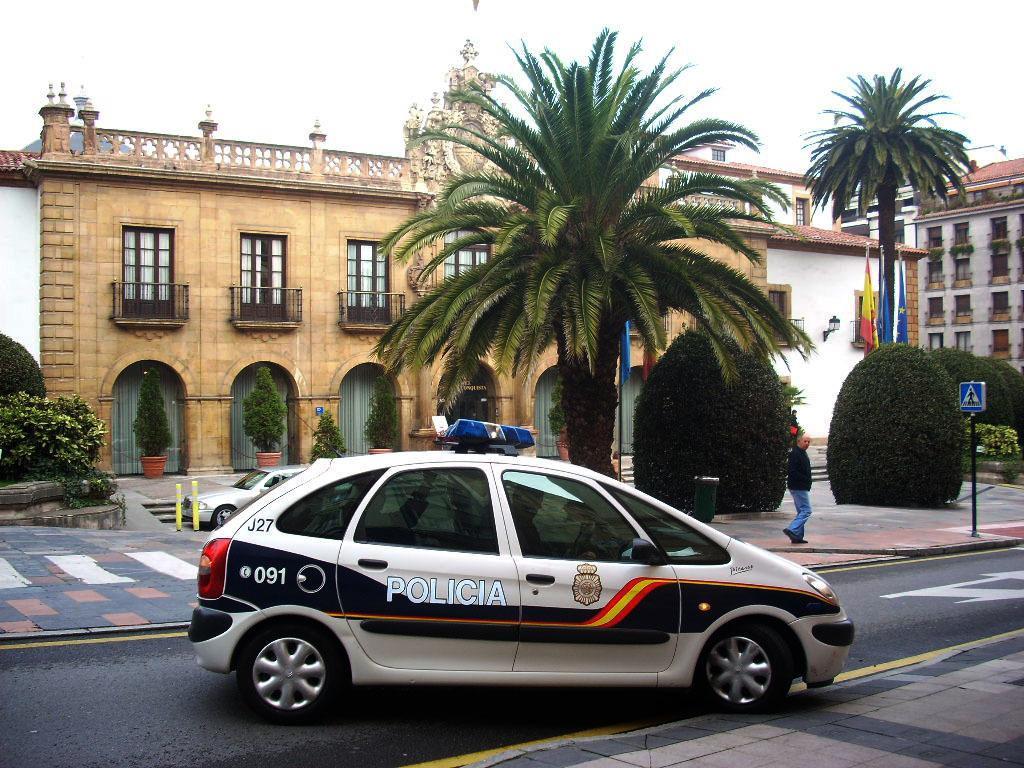In one or two sentences, can you explain what this image depicts? In this picture we can see a car on the road, trees, building with windows, flags, house plants and a man walking on a footpath and in the background we can see the sky. 